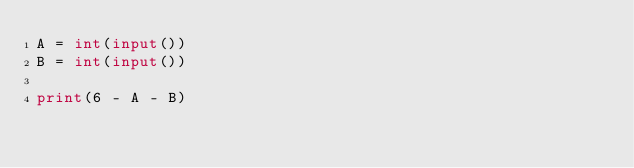Convert code to text. <code><loc_0><loc_0><loc_500><loc_500><_Python_>A = int(input())
B = int(input())

print(6 - A - B)
</code> 